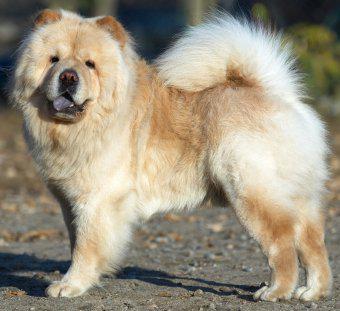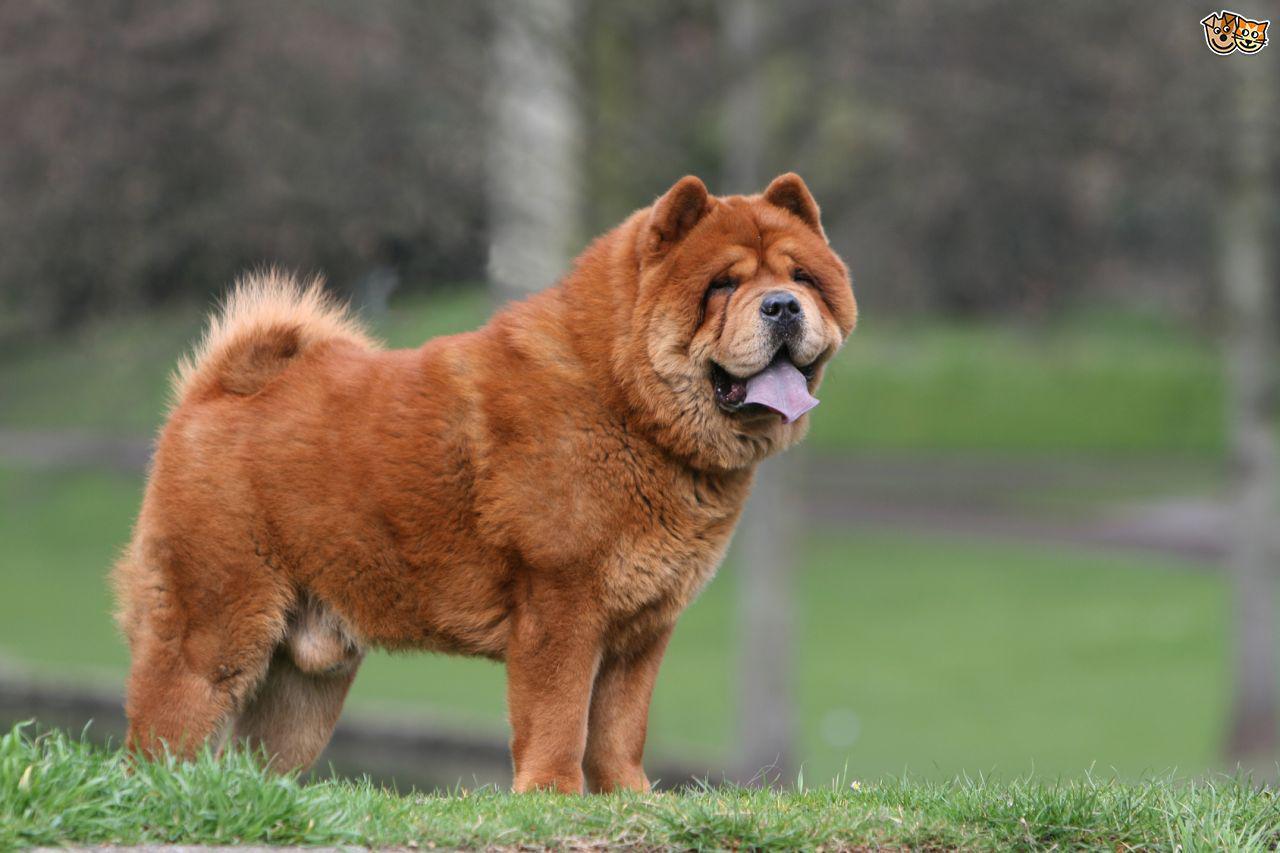The first image is the image on the left, the second image is the image on the right. For the images displayed, is the sentence "in at least one image there ia a dog fully visable on the grass" factually correct? Answer yes or no. Yes. The first image is the image on the left, the second image is the image on the right. Evaluate the accuracy of this statement regarding the images: "In at least one image, there’s a single dark brown dog with a purple tongue sticking out as his light brown tail sits on his back, while he stands.". Is it true? Answer yes or no. Yes. 